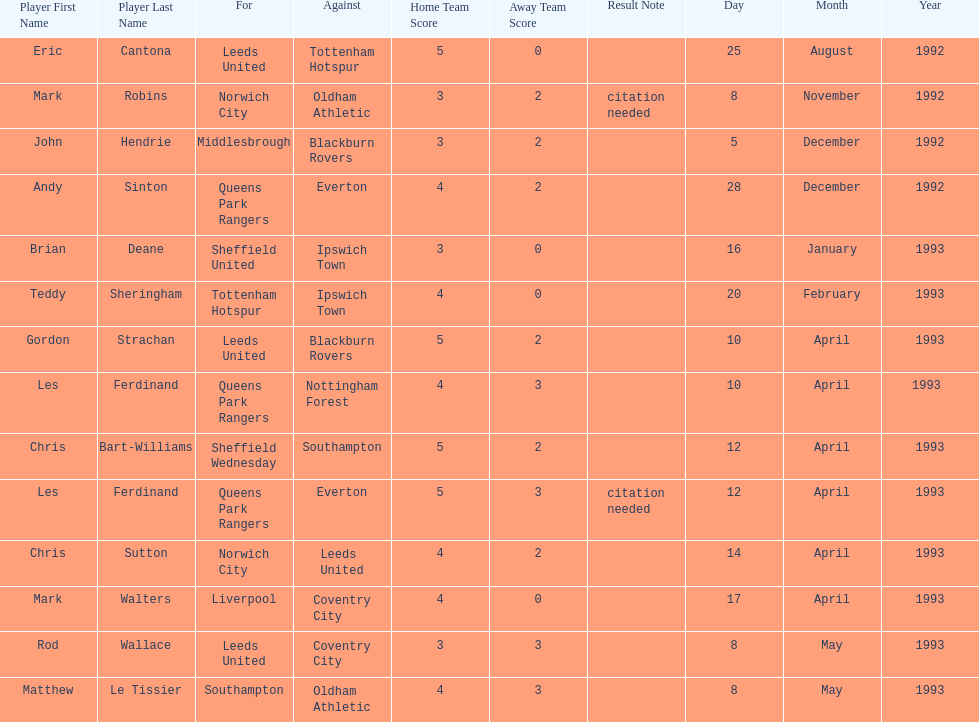Name the players for tottenham hotspur. Teddy Sheringham. 